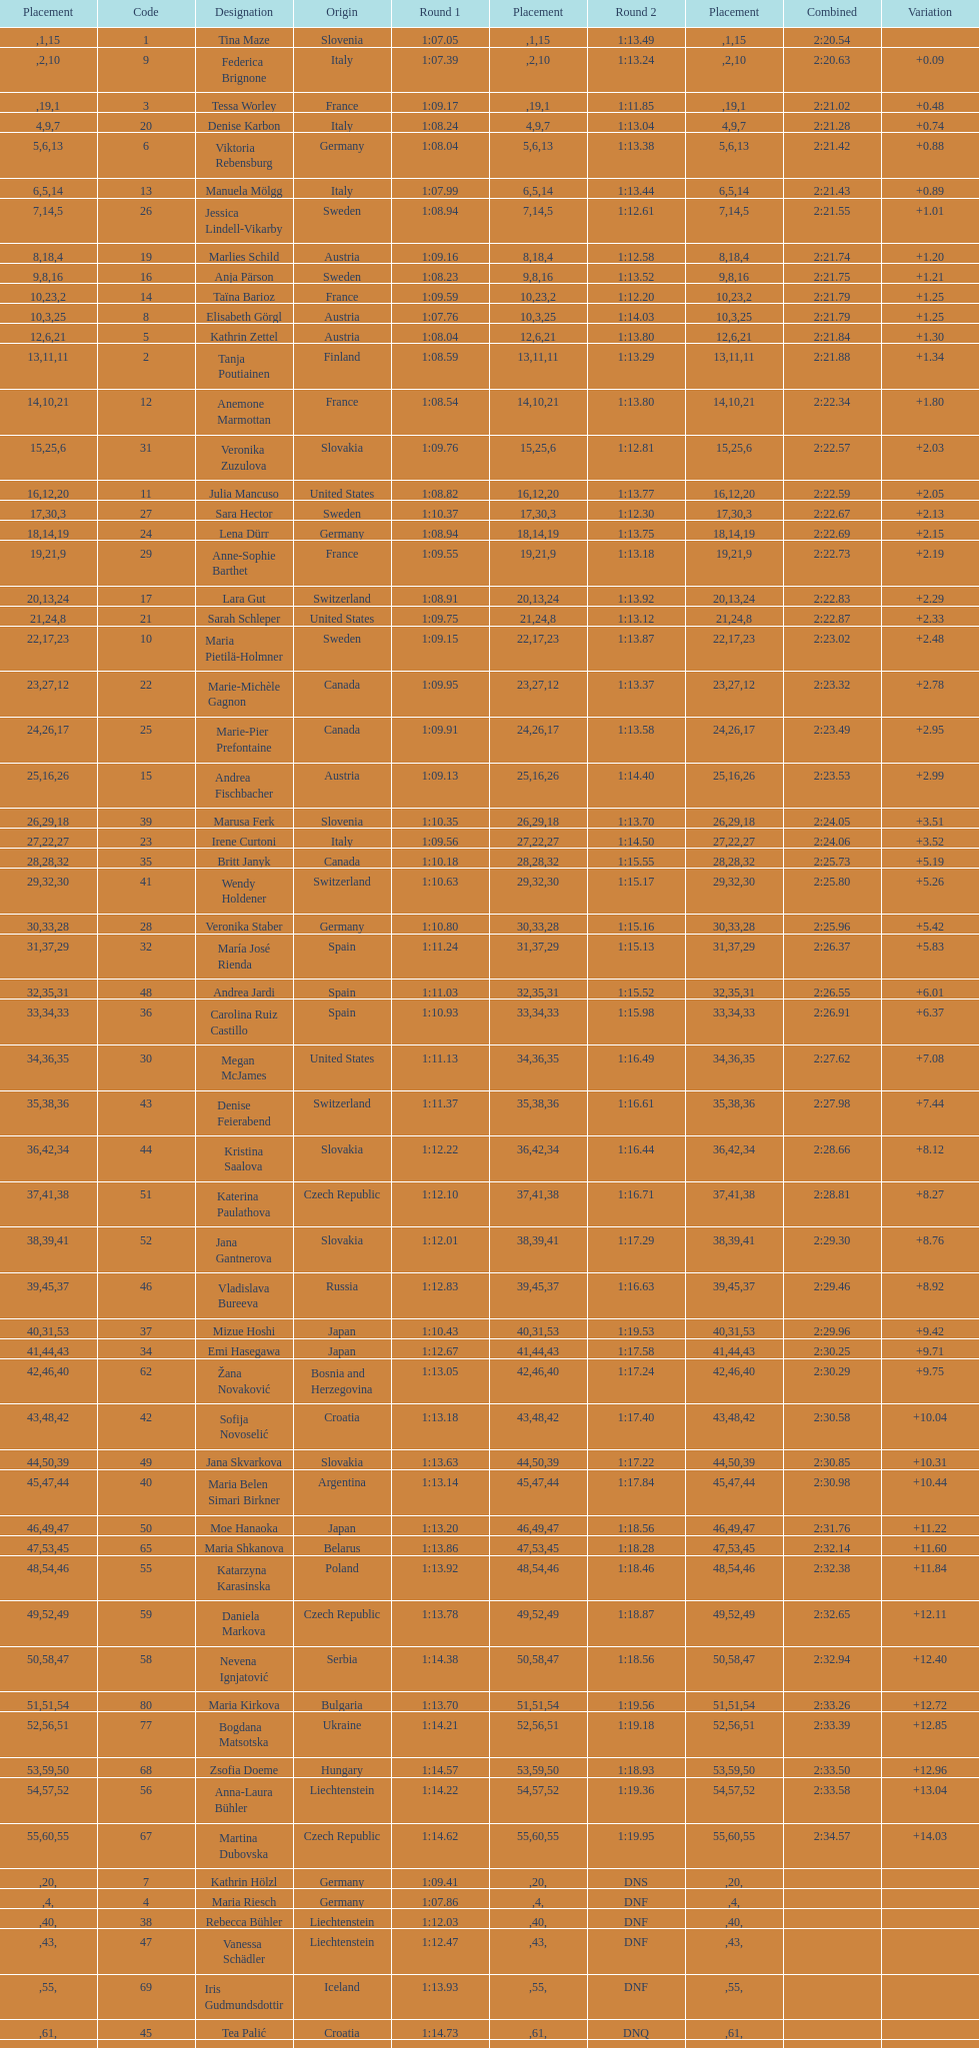Who finished next after federica brignone? Tessa Worley. 